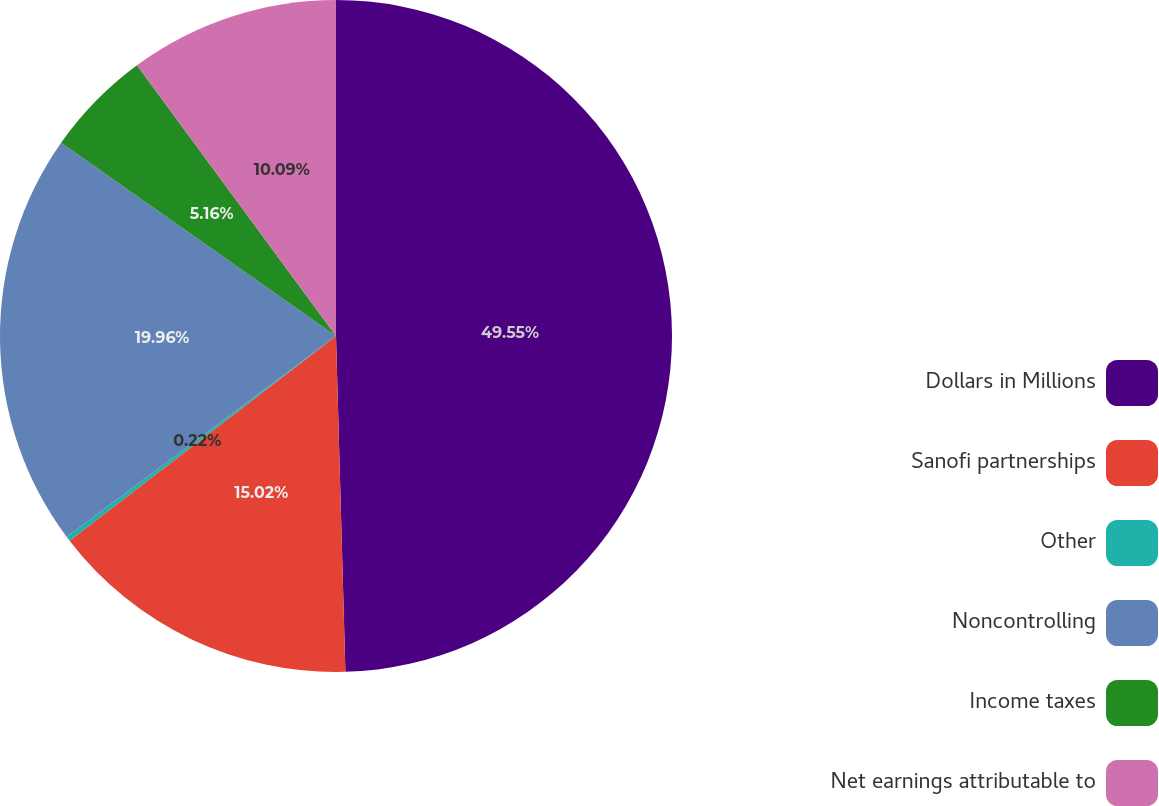<chart> <loc_0><loc_0><loc_500><loc_500><pie_chart><fcel>Dollars in Millions<fcel>Sanofi partnerships<fcel>Other<fcel>Noncontrolling<fcel>Income taxes<fcel>Net earnings attributable to<nl><fcel>49.56%<fcel>15.02%<fcel>0.22%<fcel>19.96%<fcel>5.16%<fcel>10.09%<nl></chart> 